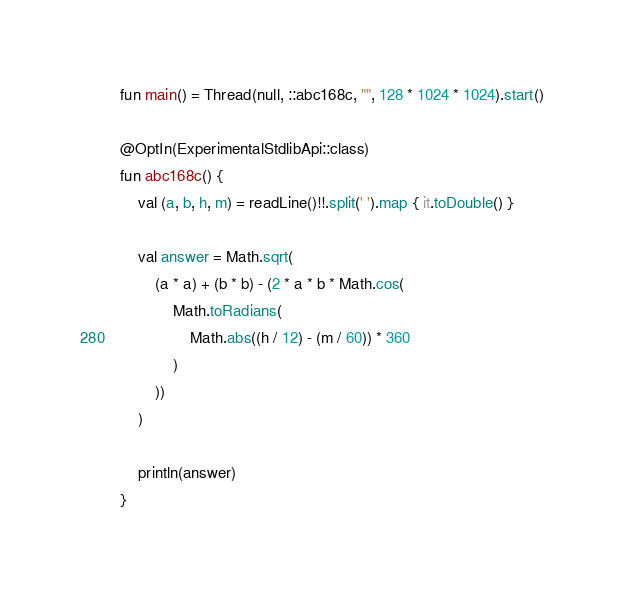<code> <loc_0><loc_0><loc_500><loc_500><_Kotlin_>fun main() = Thread(null, ::abc168c, "", 128 * 1024 * 1024).start()

@OptIn(ExperimentalStdlibApi::class)
fun abc168c() {
    val (a, b, h, m) = readLine()!!.split(' ').map { it.toDouble() }

    val answer = Math.sqrt(
        (a * a) + (b * b) - (2 * a * b * Math.cos(
            Math.toRadians(
                Math.abs((h / 12) - (m / 60)) * 360
            )
        ))
    )

    println(answer)
}
</code> 